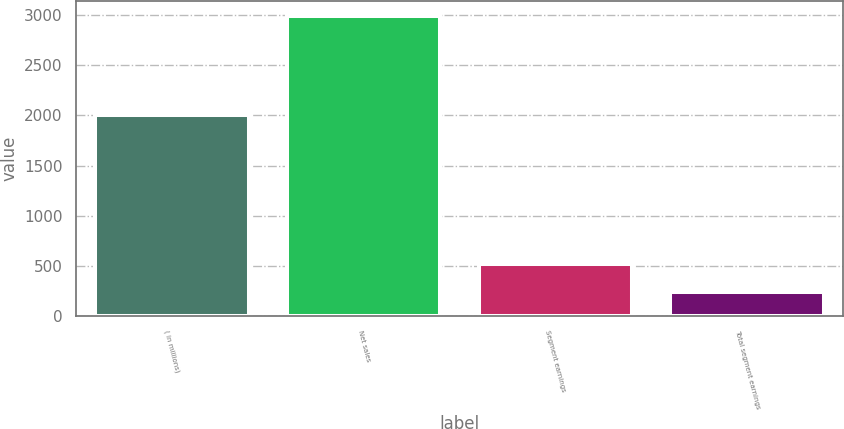Convert chart to OTSL. <chart><loc_0><loc_0><loc_500><loc_500><bar_chart><fcel>( in millions)<fcel>Net sales<fcel>Segment earnings<fcel>Total segment earnings<nl><fcel>2008<fcel>2989.5<fcel>518.1<fcel>243.5<nl></chart> 